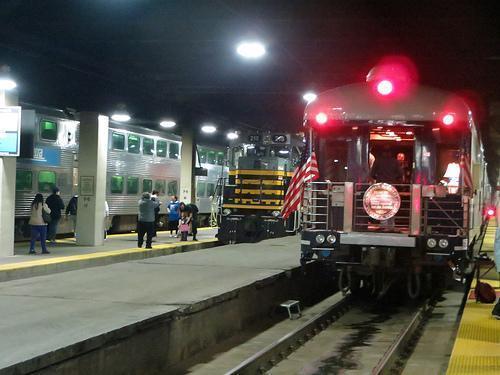How many trains are in the photo?
Give a very brief answer. 2. How many red lights are on the front of the train on the right?
Give a very brief answer. 3. 